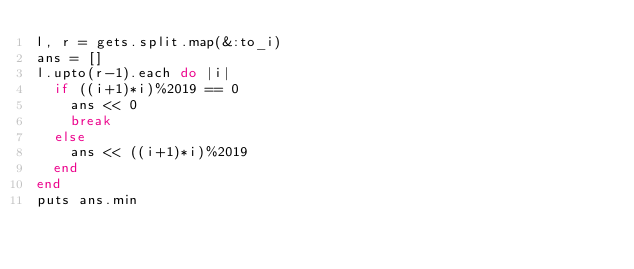<code> <loc_0><loc_0><loc_500><loc_500><_Ruby_>l, r = gets.split.map(&:to_i)
ans = []
l.upto(r-1).each do |i|
  if ((i+1)*i)%2019 == 0
    ans << 0
    break
  else
    ans << ((i+1)*i)%2019
  end
end
puts ans.min</code> 